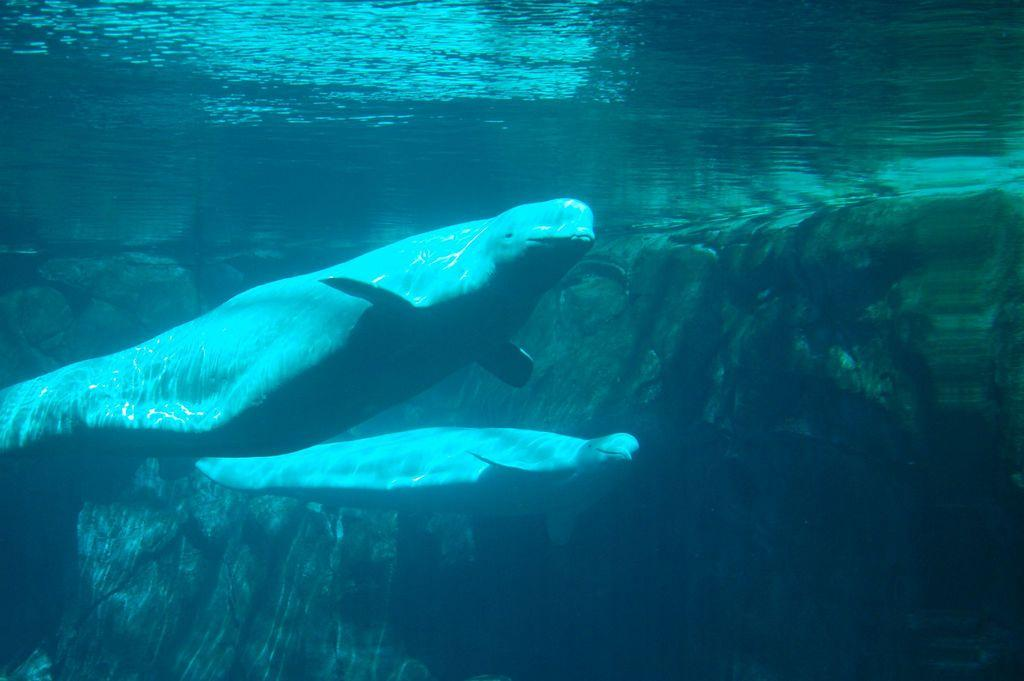What type of animals can be seen in the image? There are aquatic animals in the image. Where are the aquatic animals located? The aquatic animals are in the water. What can be seen in the background of the image? There appears to be a rock in the background of the image. What type of crib is visible in the image? There is no crib present in the image; it features aquatic animals in the water. 